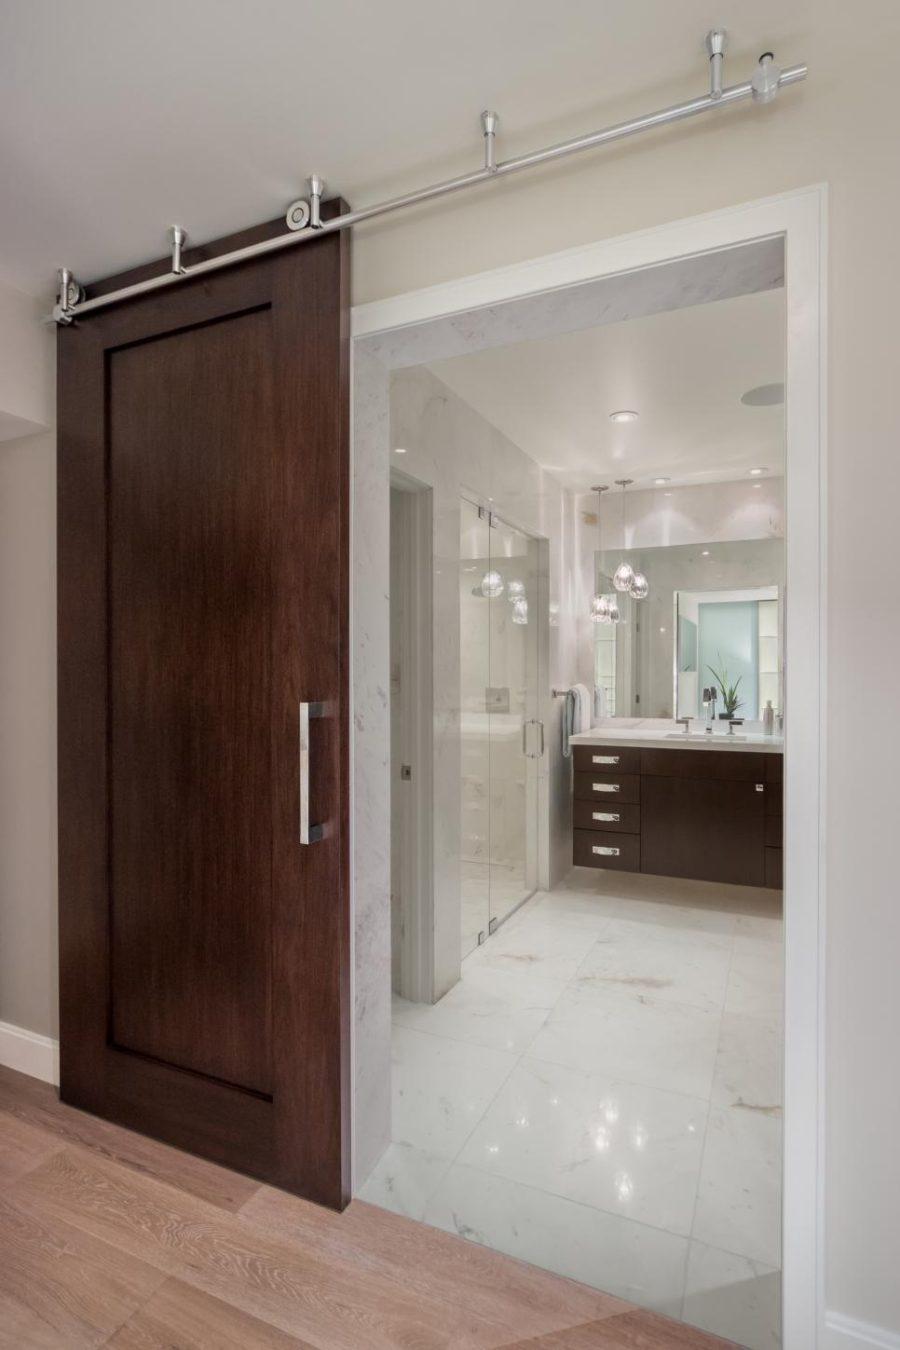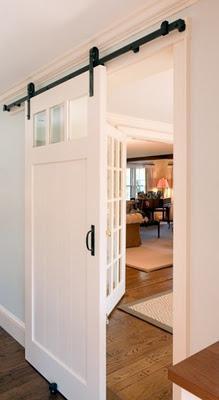The first image is the image on the left, the second image is the image on the right. For the images displayed, is the sentence "The left and right image contains the same number of hanging doors." factually correct? Answer yes or no. Yes. The first image is the image on the left, the second image is the image on the right. For the images shown, is this caption "The left image features a 'barn style' door made of weathered-look horizontal wood boards that slides on a black bar at the top." true? Answer yes or no. No. 